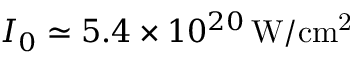<formula> <loc_0><loc_0><loc_500><loc_500>I _ { 0 } \simeq 5 . 4 \times 1 0 ^ { 2 0 } \, W / c m ^ { 2 }</formula> 